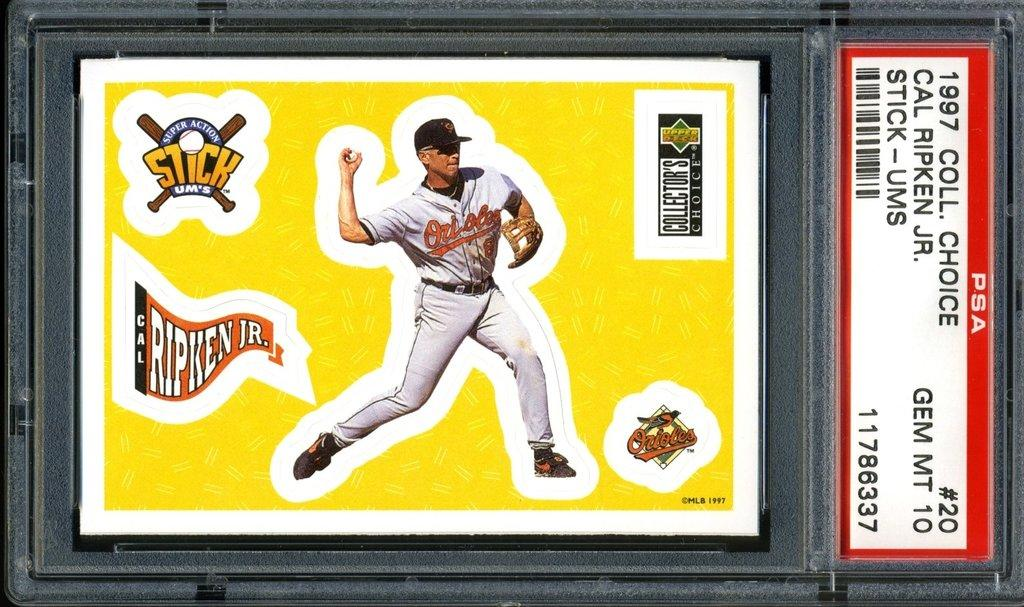<image>
Create a compact narrative representing the image presented. Baseball card of Cal Ripken Jr. that has in black letters 1997 Coll. Choice. 